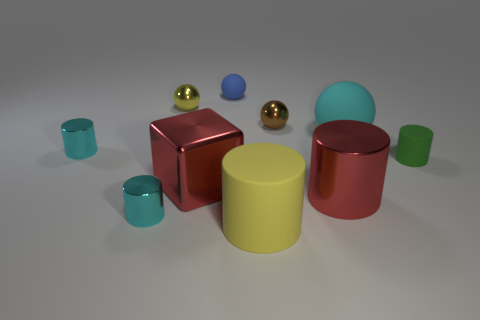How many balls are either small brown metallic objects or green objects?
Your answer should be compact. 1. Are any small red objects visible?
Give a very brief answer. No. Is there anything else that is the same shape as the brown thing?
Give a very brief answer. Yes. Does the big metallic block have the same color as the big metal cylinder?
Provide a succinct answer. Yes. What number of objects are either things that are right of the big cyan rubber ball or tiny blue rubber objects?
Make the answer very short. 2. What number of tiny shiny cylinders are left of the cyan cylinder that is in front of the cyan shiny thing behind the red metallic cylinder?
Give a very brief answer. 1. Is there any other thing that is the same size as the yellow metallic thing?
Provide a short and direct response. Yes. There is a big red shiny object to the left of the small blue matte object that is to the left of the tiny ball that is in front of the small yellow shiny ball; what is its shape?
Offer a terse response. Cube. What number of other things are there of the same color as the large metal cylinder?
Your answer should be compact. 1. There is a yellow rubber object that is in front of the rubber sphere that is left of the large shiny cylinder; what is its shape?
Give a very brief answer. Cylinder. 